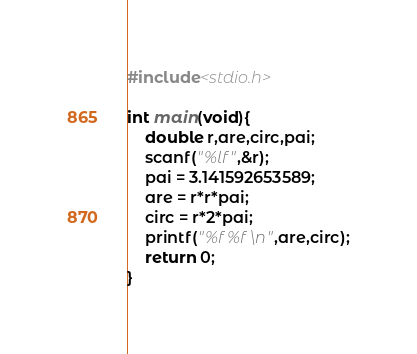Convert code to text. <code><loc_0><loc_0><loc_500><loc_500><_C++_>#include<stdio.h>

int main(void){
	double r,are,circ,pai;
	scanf("%lf",&r);
	pai = 3.141592653589;
	are = r*r*pai;
	circ = r*2*pai;
	printf("%f %f\n",are,circ);
	return 0;
}</code> 